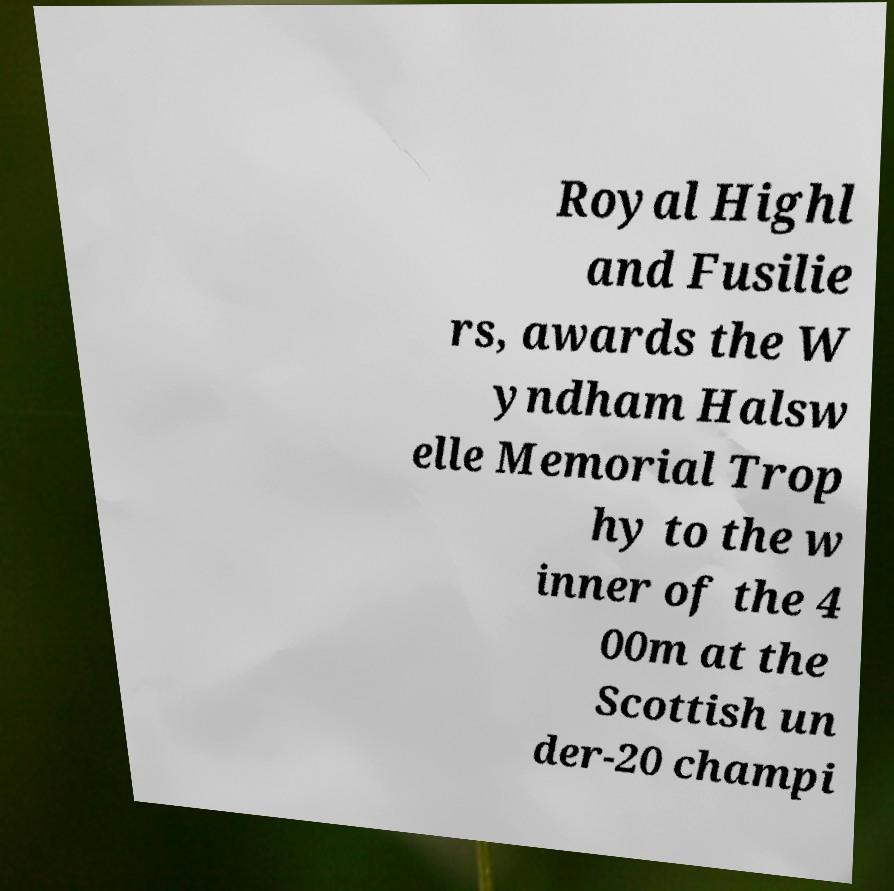I need the written content from this picture converted into text. Can you do that? Royal Highl and Fusilie rs, awards the W yndham Halsw elle Memorial Trop hy to the w inner of the 4 00m at the Scottish un der-20 champi 